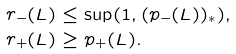Convert formula to latex. <formula><loc_0><loc_0><loc_500><loc_500>r _ { - } ( L ) & \leq \sup ( 1 , ( p _ { - } ( L ) ) _ { * } ) , \\ r _ { + } ( L ) & \geq p _ { + } ( L ) .</formula> 